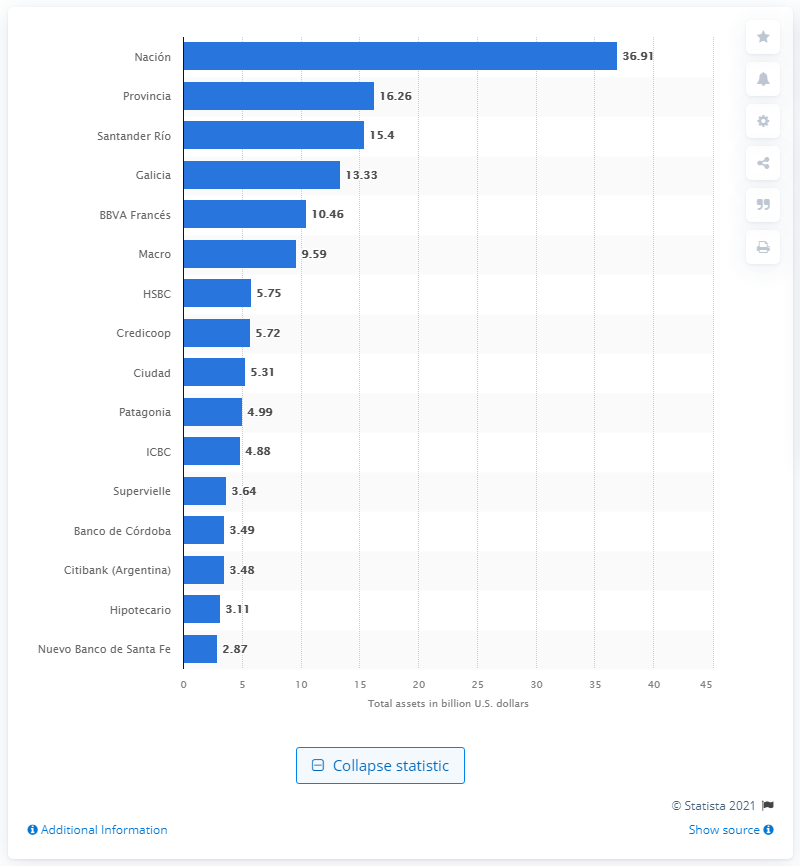Specify some key components in this picture. Banco Provincia's total assets were worth 16.26... The total assets of Banco Nacional were worth 36.91. 